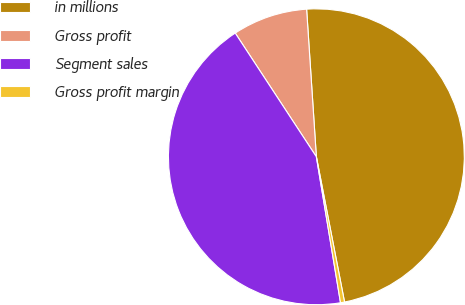Convert chart. <chart><loc_0><loc_0><loc_500><loc_500><pie_chart><fcel>in millions<fcel>Gross profit<fcel>Segment sales<fcel>Gross profit margin<nl><fcel>48.0%<fcel>8.19%<fcel>43.37%<fcel>0.44%<nl></chart> 